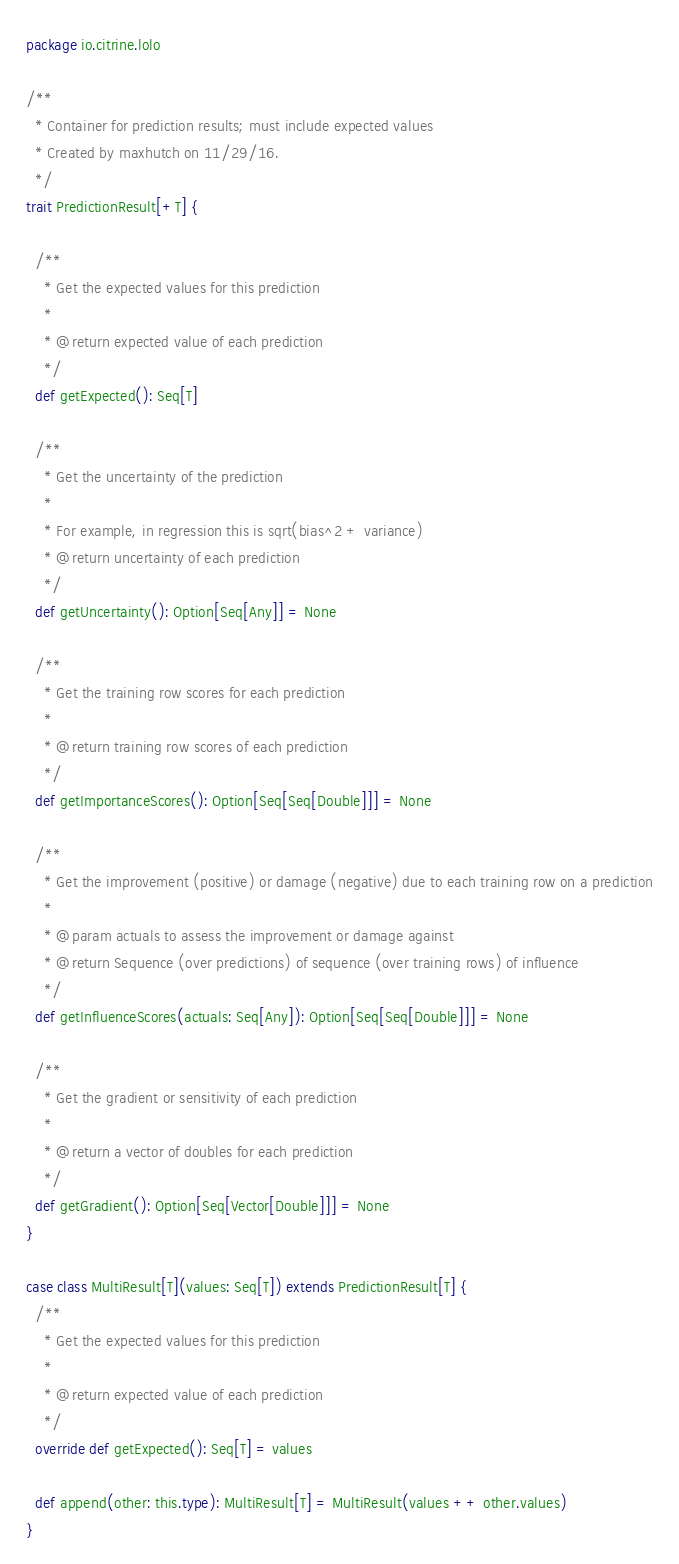<code> <loc_0><loc_0><loc_500><loc_500><_Scala_>package io.citrine.lolo

/**
  * Container for prediction results; must include expected values
  * Created by maxhutch on 11/29/16.
  */
trait PredictionResult[+T] {

  /**
    * Get the expected values for this prediction
    *
    * @return expected value of each prediction
    */
  def getExpected(): Seq[T]

  /**
    * Get the uncertainty of the prediction
    *
    * For example, in regression this is sqrt(bias^2 + variance)
    * @return uncertainty of each prediction
    */
  def getUncertainty(): Option[Seq[Any]] = None

  /**
    * Get the training row scores for each prediction
    *
    * @return training row scores of each prediction
    */
  def getImportanceScores(): Option[Seq[Seq[Double]]] = None

  /**
    * Get the improvement (positive) or damage (negative) due to each training row on a prediction
    *
    * @param actuals to assess the improvement or damage against
    * @return Sequence (over predictions) of sequence (over training rows) of influence
    */
  def getInfluenceScores(actuals: Seq[Any]): Option[Seq[Seq[Double]]] = None

  /**
    * Get the gradient or sensitivity of each prediction
    *
    * @return a vector of doubles for each prediction
    */
  def getGradient(): Option[Seq[Vector[Double]]] = None
}

case class MultiResult[T](values: Seq[T]) extends PredictionResult[T] {
  /**
    * Get the expected values for this prediction
    *
    * @return expected value of each prediction
    */
  override def getExpected(): Seq[T] = values

  def append(other: this.type): MultiResult[T] = MultiResult(values ++ other.values)
}
</code> 